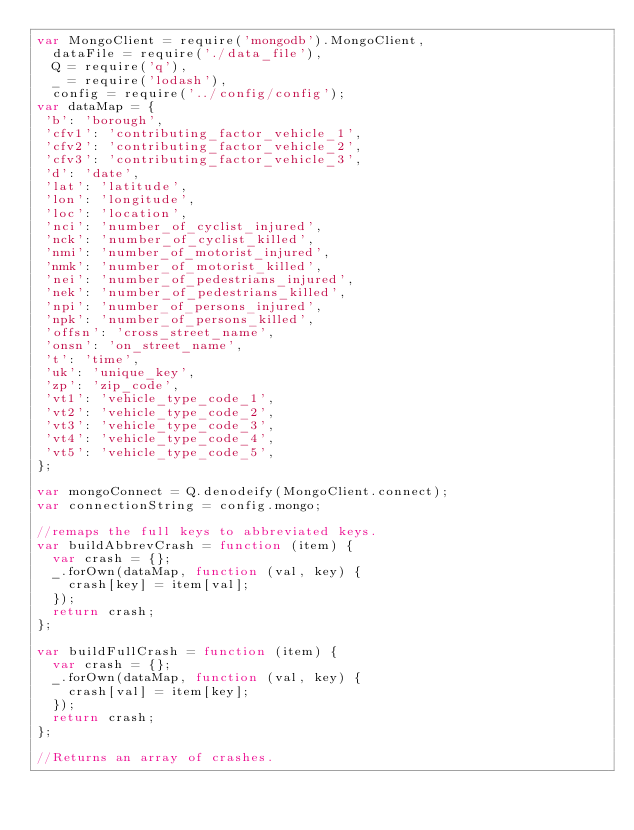<code> <loc_0><loc_0><loc_500><loc_500><_JavaScript_>var MongoClient = require('mongodb').MongoClient,
  dataFile = require('./data_file'),
  Q = require('q'),
  _ = require('lodash'),
  config = require('../config/config');
var dataMap = {
 'b': 'borough',
 'cfv1': 'contributing_factor_vehicle_1',
 'cfv2': 'contributing_factor_vehicle_2',
 'cfv3': 'contributing_factor_vehicle_3',
 'd': 'date',
 'lat': 'latitude',
 'lon': 'longitude',
 'loc': 'location',
 'nci': 'number_of_cyclist_injured',
 'nck': 'number_of_cyclist_killed',
 'nmi': 'number_of_motorist_injured',
 'nmk': 'number_of_motorist_killed',
 'nei': 'number_of_pedestrians_injured',
 'nek': 'number_of_pedestrians_killed',
 'npi': 'number_of_persons_injured',
 'npk': 'number_of_persons_killed',
 'offsn': 'cross_street_name',
 'onsn': 'on_street_name',
 't': 'time',
 'uk': 'unique_key',
 'zp': 'zip_code',
 'vt1': 'vehicle_type_code_1',
 'vt2': 'vehicle_type_code_2',
 'vt3': 'vehicle_type_code_3',
 'vt4': 'vehicle_type_code_4',
 'vt5': 'vehicle_type_code_5',
};

var mongoConnect = Q.denodeify(MongoClient.connect);
var connectionString = config.mongo;

//remaps the full keys to abbreviated keys.
var buildAbbrevCrash = function (item) {
  var crash = {};
  _.forOwn(dataMap, function (val, key) {
    crash[key] = item[val];
  });
  return crash;
};

var buildFullCrash = function (item) {
  var crash = {};
  _.forOwn(dataMap, function (val, key) {
    crash[val] = item[key];
  });
  return crash;
};

//Returns an array of crashes.</code> 